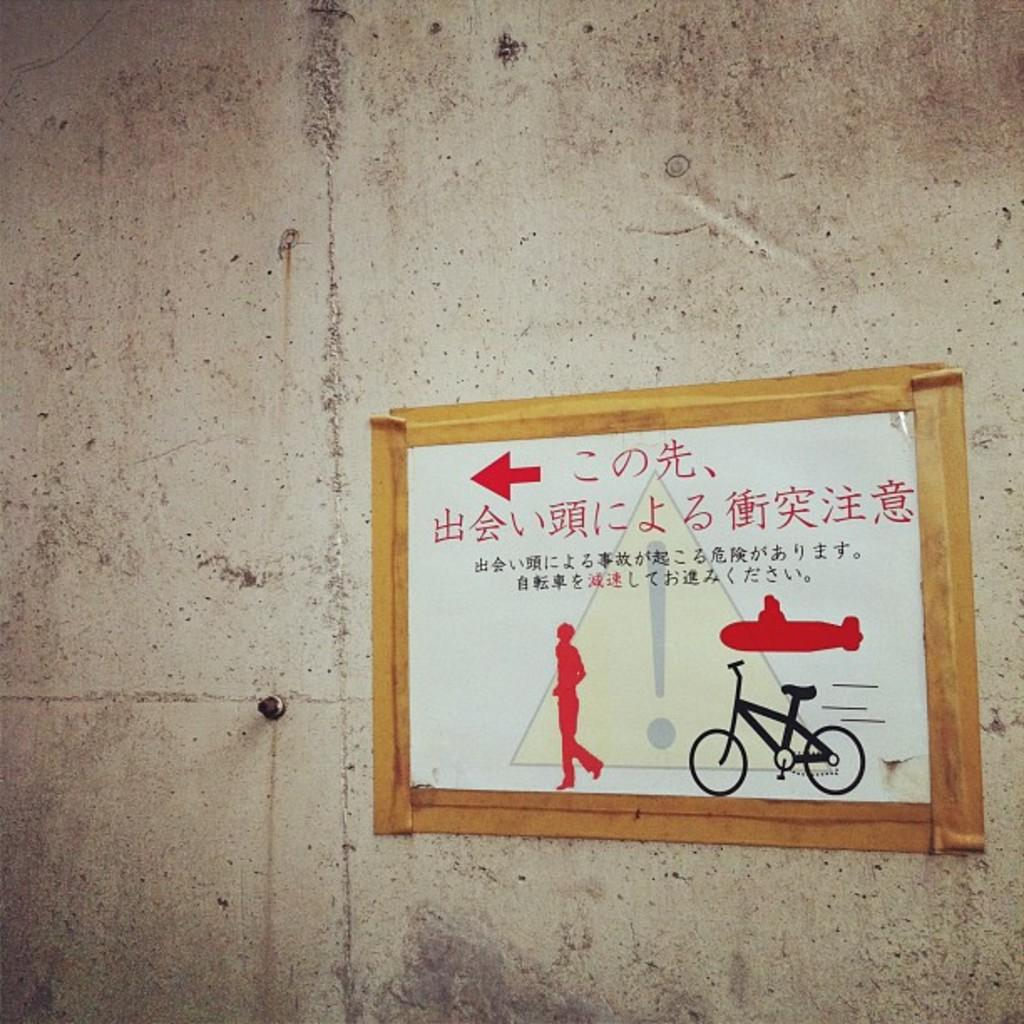What is present on the wall in the image? There is a poster in the image. How is the poster secured to the wall? The poster is attached to the wall. What action does the father take in the image? There is no father or action present in the image; it only features a poster attached to a wall. 